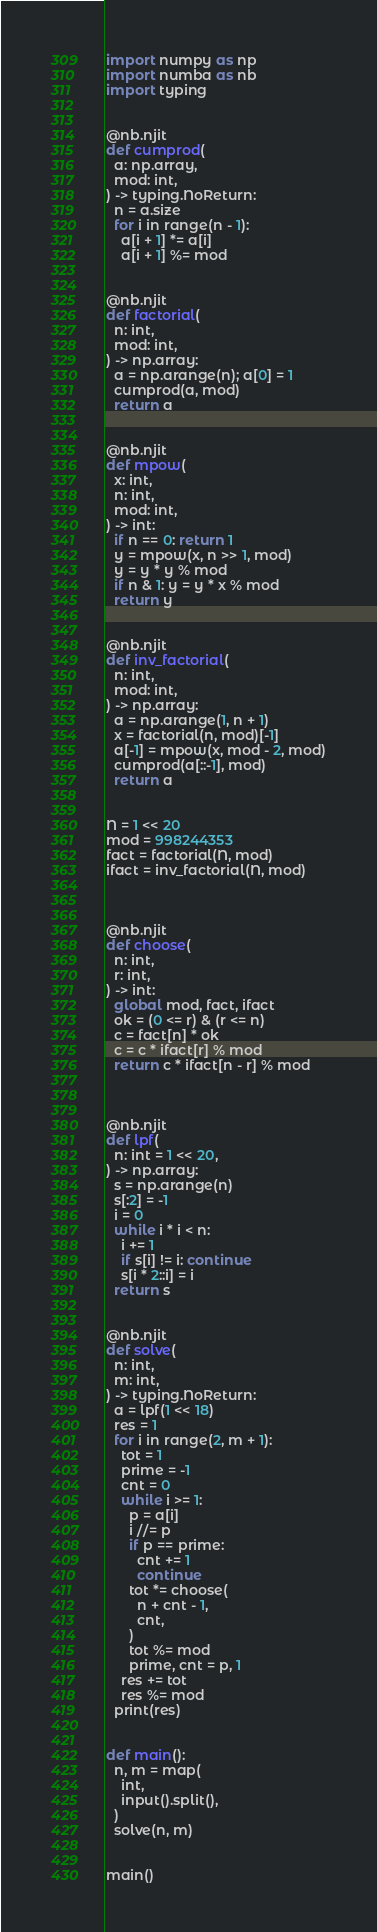<code> <loc_0><loc_0><loc_500><loc_500><_Python_>import numpy as np 
import numba as nb
import typing


@nb.njit
def cumprod(
  a: np.array,
  mod: int,
) -> typing.NoReturn:
  n = a.size
  for i in range(n - 1):
    a[i + 1] *= a[i]
    a[i + 1] %= mod


@nb.njit
def factorial(
  n: int,
  mod: int,
) -> np.array:
  a = np.arange(n); a[0] = 1
  cumprod(a, mod)
  return a


@nb.njit
def mpow(
  x: int,
  n: int,
  mod: int,
) -> int:
  if n == 0: return 1
  y = mpow(x, n >> 1, mod)
  y = y * y % mod
  if n & 1: y = y * x % mod
  return y


@nb.njit
def inv_factorial(
  n: int,
  mod: int,
) -> np.array:
  a = np.arange(1, n + 1)
  x = factorial(n, mod)[-1]
  a[-1] = mpow(x, mod - 2, mod)
  cumprod(a[::-1], mod)
  return a


N = 1 << 20
mod = 998244353
fact = factorial(N, mod)
ifact = inv_factorial(N, mod)



@nb.njit
def choose(
  n: int,
  r: int,
) -> int:
  global mod, fact, ifact
  ok = (0 <= r) & (r <= n)
  c = fact[n] * ok
  c = c * ifact[r] % mod
  return c * ifact[n - r] % mod



@nb.njit
def lpf(
  n: int = 1 << 20,
) -> np.array:
  s = np.arange(n)
  s[:2] = -1
  i = 0 
  while i * i < n:
    i += 1
    if s[i] != i: continue
    s[i * 2::i] = i
  return s


@nb.njit
def solve(
  n: int,
  m: int,
) -> typing.NoReturn:
  a = lpf(1 << 18)
  res = 1
  for i in range(2, m + 1):
    tot = 1
    prime = -1
    cnt = 0
    while i >= 1:
      p = a[i]
      i //= p
      if p == prime:
        cnt += 1
        continue
      tot *= choose(
        n + cnt - 1,
        cnt,
      )
      tot %= mod
      prime, cnt = p, 1
    res += tot
    res %= mod
  print(res)


def main():
  n, m = map(
    int,
    input().split(),
  )
  solve(n, m)


main()
</code> 